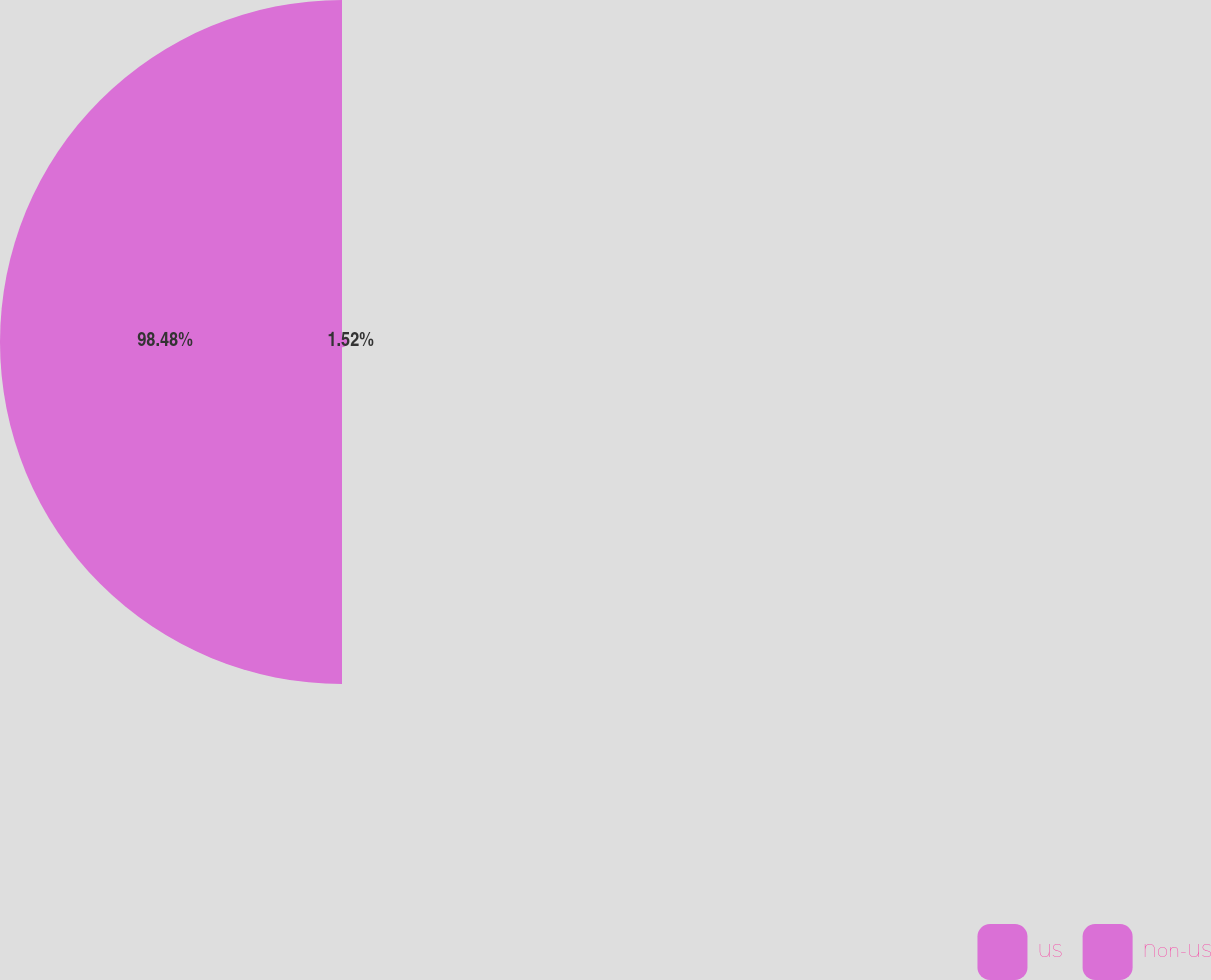Convert chart. <chart><loc_0><loc_0><loc_500><loc_500><pie_chart><fcel>US<fcel>Non-US<nl><fcel>1.52%<fcel>98.48%<nl></chart> 